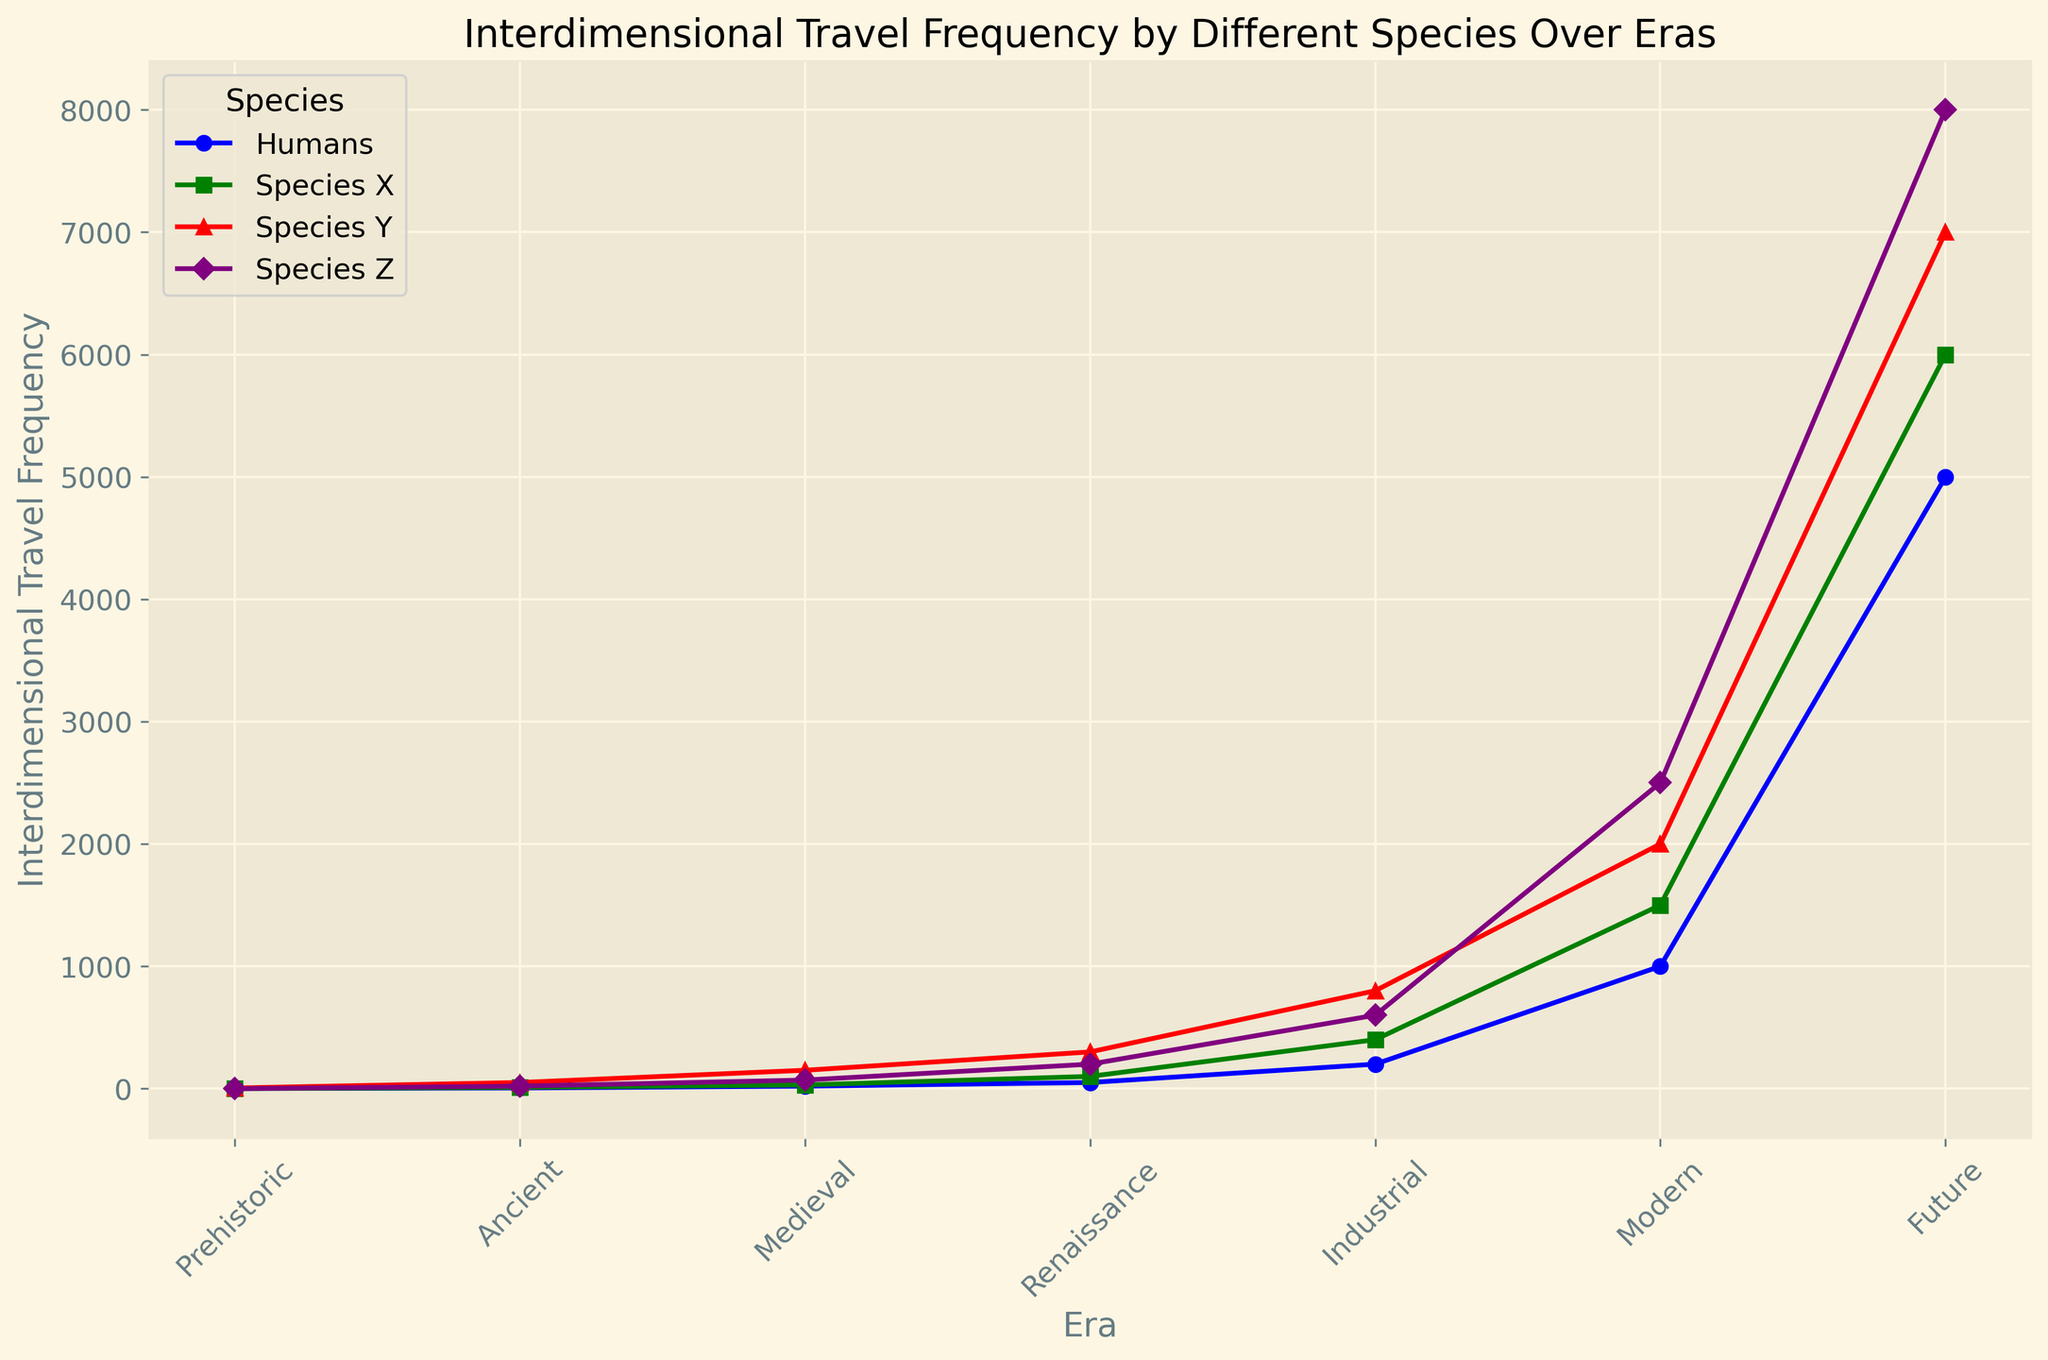Which species shows the highest frequency of interdimensional travel in the Future era? The figure indicates the highest frequency of interdimensional travel for each species separately. By comparing the frequencies in the Future era, Species Z has the highest at 8000.
Answer: Species Z How does the interdimensional travel frequency of Humans in the Medieval era compare with that of Species X in the Ancient era? By examining the line chart, Humans have a frequency of 20 in the Medieval era while Species X shows a frequency of 10 in the Ancient era. Thus, Humans have a higher frequency in those respective eras.
Answer: Humans are higher Which species has the steepest increase in frequency from the Prehistoric to the Modern era? The steepness of the increase can be visually identified by the slope of the lines on the chart. Species Z’s frequency increases from 0 in the Prehistoric era to 2500 in the Modern era, a significant change indicating a steep increase.
Answer: Species Z What is the average interdimensional travel frequency of Species Y across the Ancient, Medieval, and Renaissance eras? The frequencies for Species Y in these eras are 50, 150, and 300 respectively. Summing these gives 500, and dividing by 3 for the number of eras: (50 + 150 + 300) / 3 = 500 / 3 ≈ 166.67
Answer: ≈ 166.67 To the nearest thousand, how much more frequent is the interdimensional travel of Species Z in the Future era compared to Species X in the same era? In the Future era, Species Z has a frequency of 8000, and Species X has a frequency of 6000. Subtracting these gives: 8000 - 6000 = 2000
Answer: 2000 Which era shows the greatest difference in interdimensional travel frequency between Species Y and Humans? The difference is calculated for each era and the greatest is identified: Prehistoric (5-1=4), Ancient (50-5=45), Medieval (150-20=130), Renaissance (300-50=250), Industrial (800-200=600), Modern (2000-1000=1000), Future (7000-5000=2000). The greatest difference is 2000 in the Future era.
Answer: Future From Renaissance to Modern era, which species shows the highest overall increase in interdimensional travel frequency? Calculating the frequency increase for each species: Humans (1000 - 50 = 950), Species X (1500 - 100 = 1400), Species Y (2000 - 300 = 1700), Species Z (2500 - 200 = 2300). Species Z has the highest increase of 2300.
Answer: Species Z Compare the rate of change in interdimensional travel frequency for Species X between Ancient and Industrial eras and for Humans between Medieval and Industrial eras. For Species X: (400 - 10) / (Industrial - Ancient) = 390, for Humans: (200 - 20) / (Industrial - Medieval) = 180. Species X has a higher rate of change.
Answer: Species X Which species has the least frequency of interdimensional travel in the Industrial era, and what is its value? In the Industrial era, the frequencies are Humans (200), Species X (400), Species Y (800), and Species Z (600). Humans have the least frequency at 200.
Answer: Humans, 200 